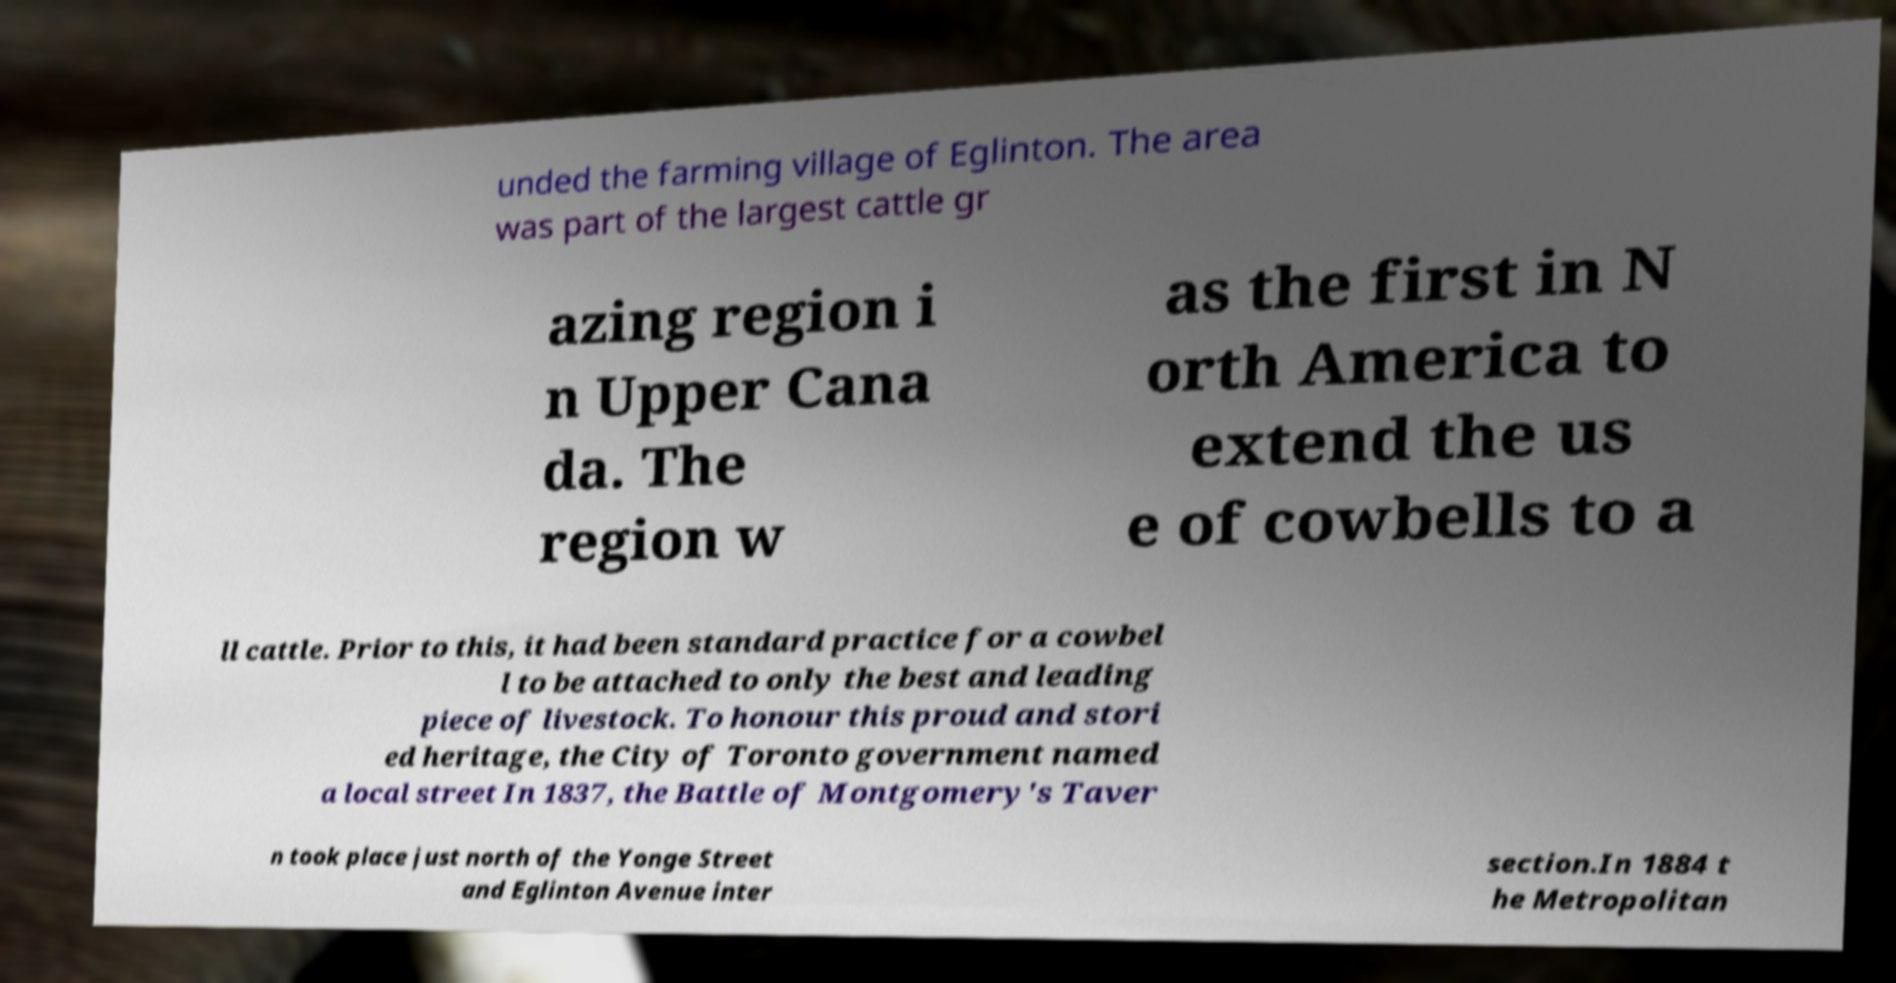There's text embedded in this image that I need extracted. Can you transcribe it verbatim? unded the farming village of Eglinton. The area was part of the largest cattle gr azing region i n Upper Cana da. The region w as the first in N orth America to extend the us e of cowbells to a ll cattle. Prior to this, it had been standard practice for a cowbel l to be attached to only the best and leading piece of livestock. To honour this proud and stori ed heritage, the City of Toronto government named a local street In 1837, the Battle of Montgomery's Taver n took place just north of the Yonge Street and Eglinton Avenue inter section.In 1884 t he Metropolitan 